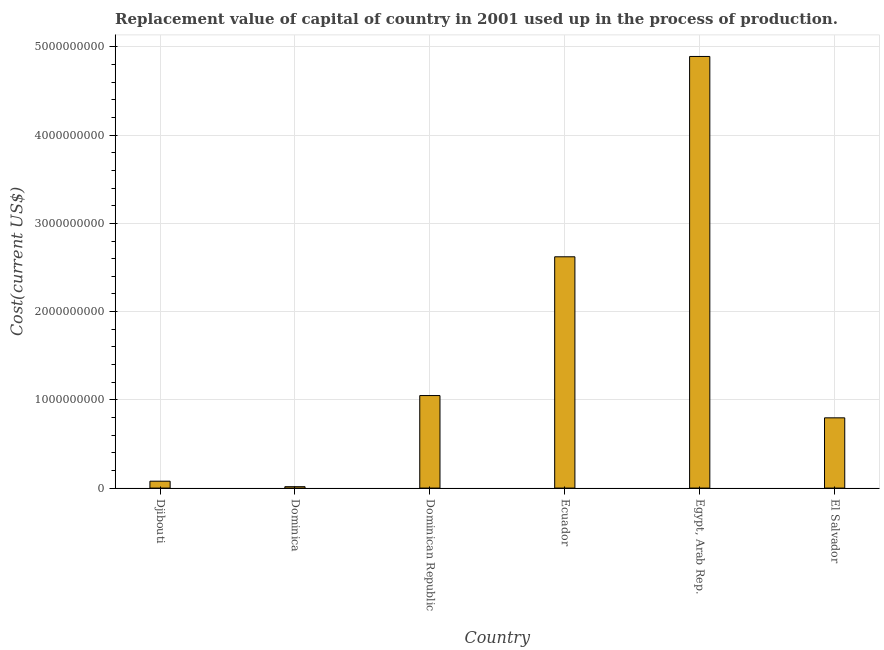Does the graph contain grids?
Offer a terse response. Yes. What is the title of the graph?
Make the answer very short. Replacement value of capital of country in 2001 used up in the process of production. What is the label or title of the Y-axis?
Give a very brief answer. Cost(current US$). What is the consumption of fixed capital in Ecuador?
Give a very brief answer. 2.62e+09. Across all countries, what is the maximum consumption of fixed capital?
Your response must be concise. 4.89e+09. Across all countries, what is the minimum consumption of fixed capital?
Your answer should be very brief. 1.58e+07. In which country was the consumption of fixed capital maximum?
Offer a terse response. Egypt, Arab Rep. In which country was the consumption of fixed capital minimum?
Give a very brief answer. Dominica. What is the sum of the consumption of fixed capital?
Your response must be concise. 9.45e+09. What is the difference between the consumption of fixed capital in Dominican Republic and Ecuador?
Make the answer very short. -1.57e+09. What is the average consumption of fixed capital per country?
Offer a very short reply. 1.58e+09. What is the median consumption of fixed capital?
Offer a very short reply. 9.23e+08. In how many countries, is the consumption of fixed capital greater than 1800000000 US$?
Your response must be concise. 2. What is the ratio of the consumption of fixed capital in Dominica to that in Egypt, Arab Rep.?
Give a very brief answer. 0. Is the consumption of fixed capital in Djibouti less than that in Ecuador?
Your answer should be very brief. Yes. Is the difference between the consumption of fixed capital in Djibouti and Dominican Republic greater than the difference between any two countries?
Give a very brief answer. No. What is the difference between the highest and the second highest consumption of fixed capital?
Keep it short and to the point. 2.27e+09. What is the difference between the highest and the lowest consumption of fixed capital?
Your response must be concise. 4.88e+09. How many countries are there in the graph?
Provide a succinct answer. 6. What is the Cost(current US$) in Djibouti?
Your response must be concise. 7.81e+07. What is the Cost(current US$) in Dominica?
Your answer should be compact. 1.58e+07. What is the Cost(current US$) in Dominican Republic?
Give a very brief answer. 1.05e+09. What is the Cost(current US$) of Ecuador?
Offer a terse response. 2.62e+09. What is the Cost(current US$) in Egypt, Arab Rep.?
Provide a short and direct response. 4.89e+09. What is the Cost(current US$) in El Salvador?
Give a very brief answer. 7.96e+08. What is the difference between the Cost(current US$) in Djibouti and Dominica?
Ensure brevity in your answer.  6.22e+07. What is the difference between the Cost(current US$) in Djibouti and Dominican Republic?
Provide a succinct answer. -9.71e+08. What is the difference between the Cost(current US$) in Djibouti and Ecuador?
Your answer should be compact. -2.54e+09. What is the difference between the Cost(current US$) in Djibouti and Egypt, Arab Rep.?
Ensure brevity in your answer.  -4.81e+09. What is the difference between the Cost(current US$) in Djibouti and El Salvador?
Provide a short and direct response. -7.18e+08. What is the difference between the Cost(current US$) in Dominica and Dominican Republic?
Your answer should be very brief. -1.03e+09. What is the difference between the Cost(current US$) in Dominica and Ecuador?
Make the answer very short. -2.61e+09. What is the difference between the Cost(current US$) in Dominica and Egypt, Arab Rep.?
Your answer should be compact. -4.88e+09. What is the difference between the Cost(current US$) in Dominica and El Salvador?
Offer a very short reply. -7.80e+08. What is the difference between the Cost(current US$) in Dominican Republic and Ecuador?
Offer a terse response. -1.57e+09. What is the difference between the Cost(current US$) in Dominican Republic and Egypt, Arab Rep.?
Offer a terse response. -3.84e+09. What is the difference between the Cost(current US$) in Dominican Republic and El Salvador?
Provide a succinct answer. 2.53e+08. What is the difference between the Cost(current US$) in Ecuador and Egypt, Arab Rep.?
Make the answer very short. -2.27e+09. What is the difference between the Cost(current US$) in Ecuador and El Salvador?
Provide a succinct answer. 1.83e+09. What is the difference between the Cost(current US$) in Egypt, Arab Rep. and El Salvador?
Give a very brief answer. 4.10e+09. What is the ratio of the Cost(current US$) in Djibouti to that in Dominica?
Ensure brevity in your answer.  4.93. What is the ratio of the Cost(current US$) in Djibouti to that in Dominican Republic?
Your answer should be compact. 0.07. What is the ratio of the Cost(current US$) in Djibouti to that in Ecuador?
Ensure brevity in your answer.  0.03. What is the ratio of the Cost(current US$) in Djibouti to that in Egypt, Arab Rep.?
Offer a terse response. 0.02. What is the ratio of the Cost(current US$) in Djibouti to that in El Salvador?
Give a very brief answer. 0.1. What is the ratio of the Cost(current US$) in Dominica to that in Dominican Republic?
Ensure brevity in your answer.  0.01. What is the ratio of the Cost(current US$) in Dominica to that in Ecuador?
Offer a terse response. 0.01. What is the ratio of the Cost(current US$) in Dominica to that in Egypt, Arab Rep.?
Your response must be concise. 0. What is the ratio of the Cost(current US$) in Dominican Republic to that in Ecuador?
Keep it short and to the point. 0.4. What is the ratio of the Cost(current US$) in Dominican Republic to that in Egypt, Arab Rep.?
Offer a terse response. 0.21. What is the ratio of the Cost(current US$) in Dominican Republic to that in El Salvador?
Make the answer very short. 1.32. What is the ratio of the Cost(current US$) in Ecuador to that in Egypt, Arab Rep.?
Give a very brief answer. 0.54. What is the ratio of the Cost(current US$) in Ecuador to that in El Salvador?
Provide a succinct answer. 3.29. What is the ratio of the Cost(current US$) in Egypt, Arab Rep. to that in El Salvador?
Make the answer very short. 6.14. 